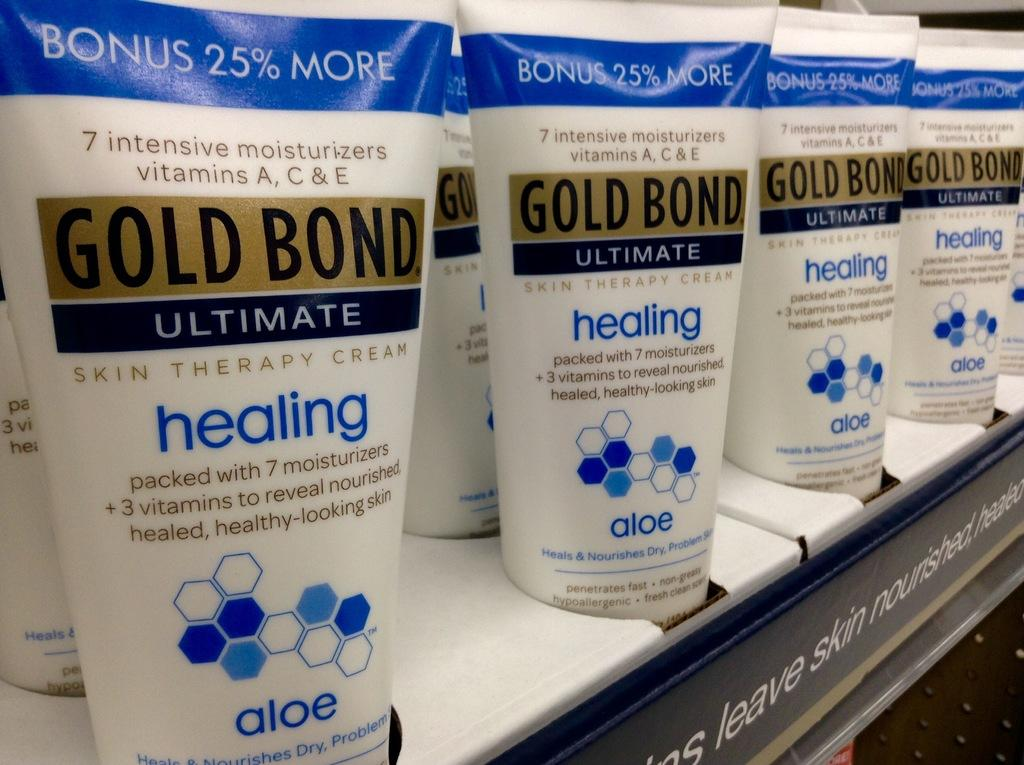Provide a one-sentence caption for the provided image. A shelf that displays bottles of Gold Bond Ultimate healing. 